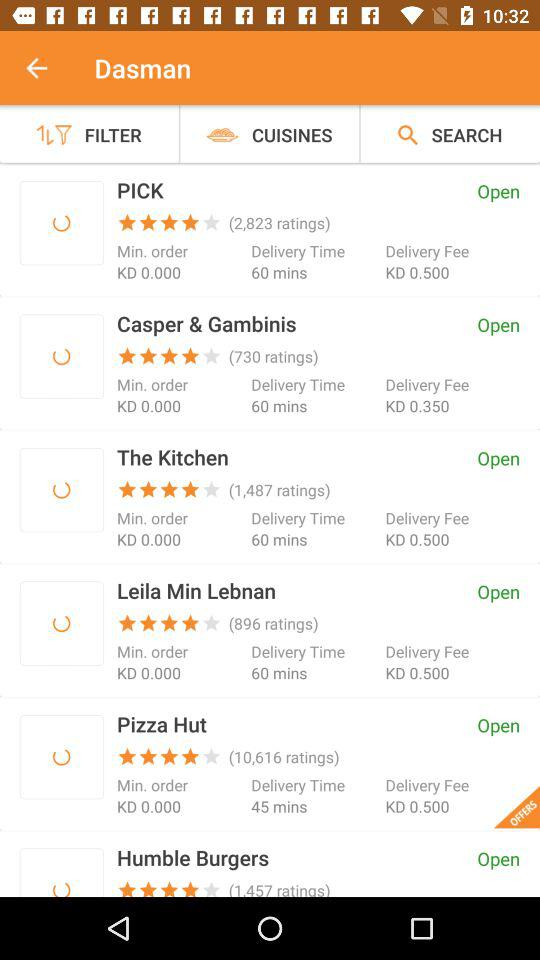How many ratings did "PICK" get? "PICK" got 2,823 ratings. 